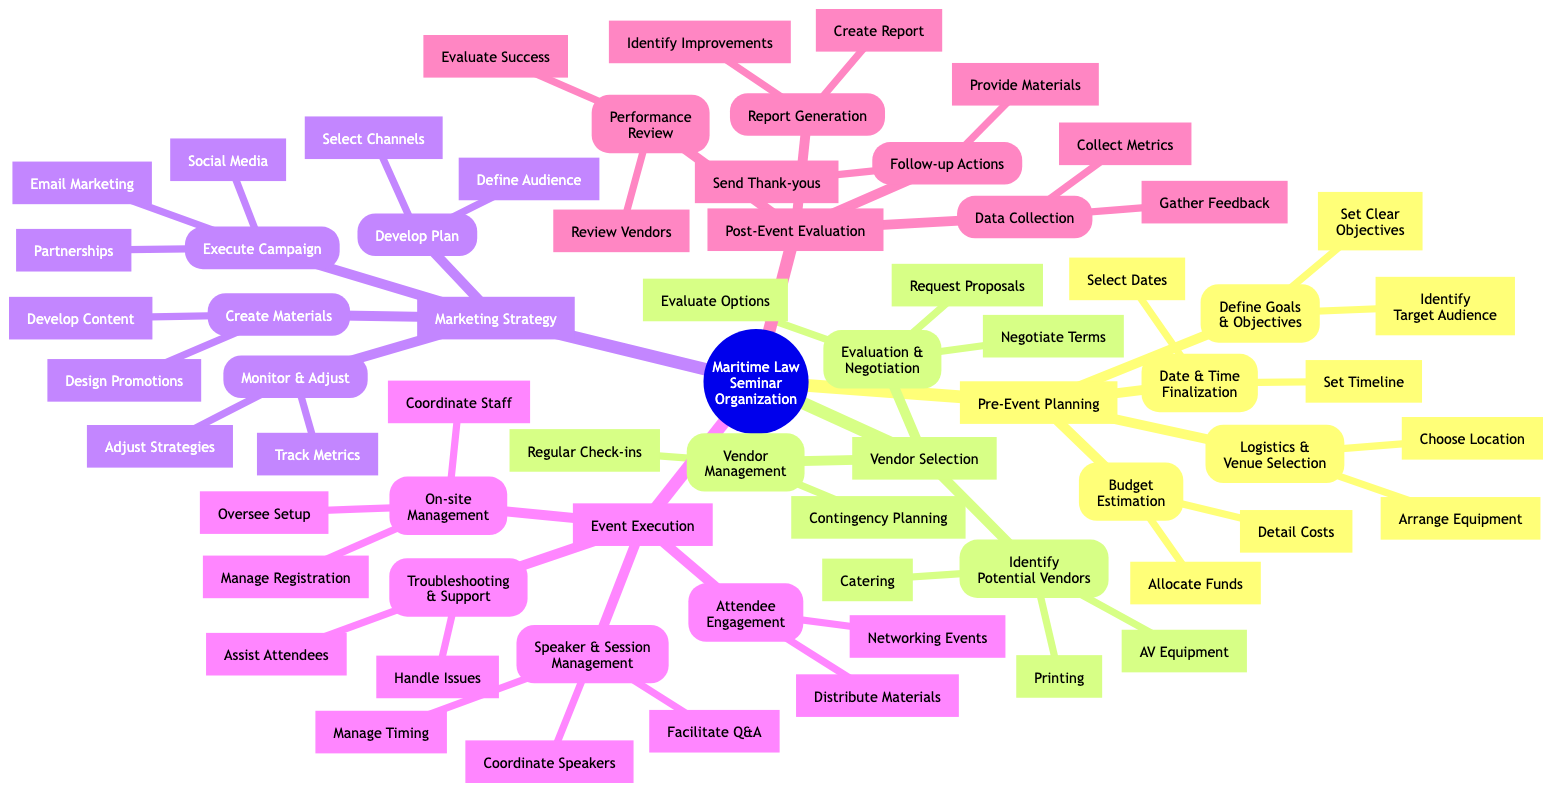what is the first key stage in organizing a maritime law seminar? The first key stage in the diagram is labeled "Pre-Event Planning," which is located at the top level under the root node.
Answer: Pre-Event Planning how many categories are under event execution? In the diagram, "Event Execution" consists of four categories: On-site Management, Speaker and Session Management, Attendee Engagement, and Troubleshooting and Support. Counting these reveals there are four categories.
Answer: 4 what is one task listed under the budget estimation category? Under the "Budget Estimation" category, one of the listed tasks is "Detail costs for venue, speakers, marketing, and materials," which can be found in the second tier linked to that category.
Answer: Detail costs for venue, speakers, marketing, and materials which category follows vendor selection in the diagram? The category that follows "Vendor Selection" is "Marketing Strategy," which is positioned directly below it on the same hierarchical level in the diagram.
Answer: Marketing Strategy how many actions are there listed under post-event evaluation? The "Post-Event Evaluation" category contains four actions: Data Collection, Performance Review, Report Generation, and Follow-up Actions. Counting these provides the total number of actions as four.
Answer: 4 which task relates to monitoring the marketing campaign? The task that relates specifically to monitoring the marketing campaign is "Track registrations and engagement metrics," which is a part of the "Monitor & Adjust" subcategory within "Marketing Strategy."
Answer: Track registrations and engagement metrics what type of vendors should be identified for a maritime law seminar? The diagram indicates that potential vendors include "AV equipment providers," "Catering services," and "Printing services," which are all listed under the "Identify Potential Vendors" category.
Answer: AV equipment providers; Catering services; Printing services what is the last action in the post-event evaluation? The last action listed under "Post-Event Evaluation" is "Provide access to event recordings and materials," which is positioned last in the "Follow-up Actions" subcategory.
Answer: Provide access to event recordings and materials 